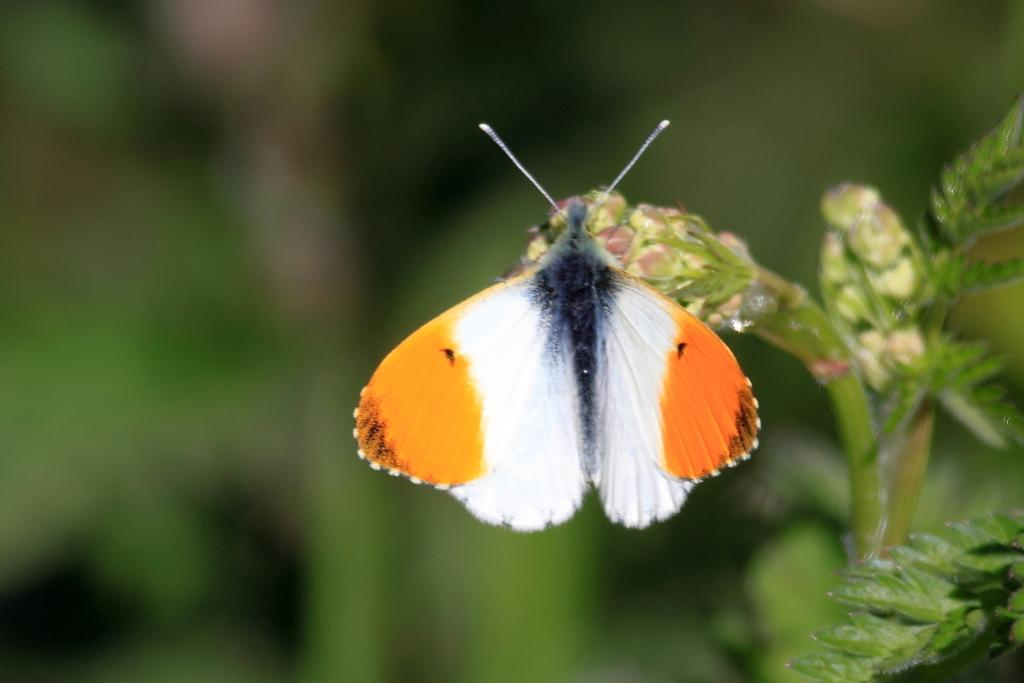What type of creature is in the image? There is a butterfly in the image. What colors can be seen on the butterfly? The butterfly has orange and white colors. What else is present in the image besides the butterfly? There is a plant in the image. What type of eggs can be seen in the image? There are no eggs present in the image; it features a butterfly and a plant. Is there a donkey visible in the image? There is no donkey present in the image. 